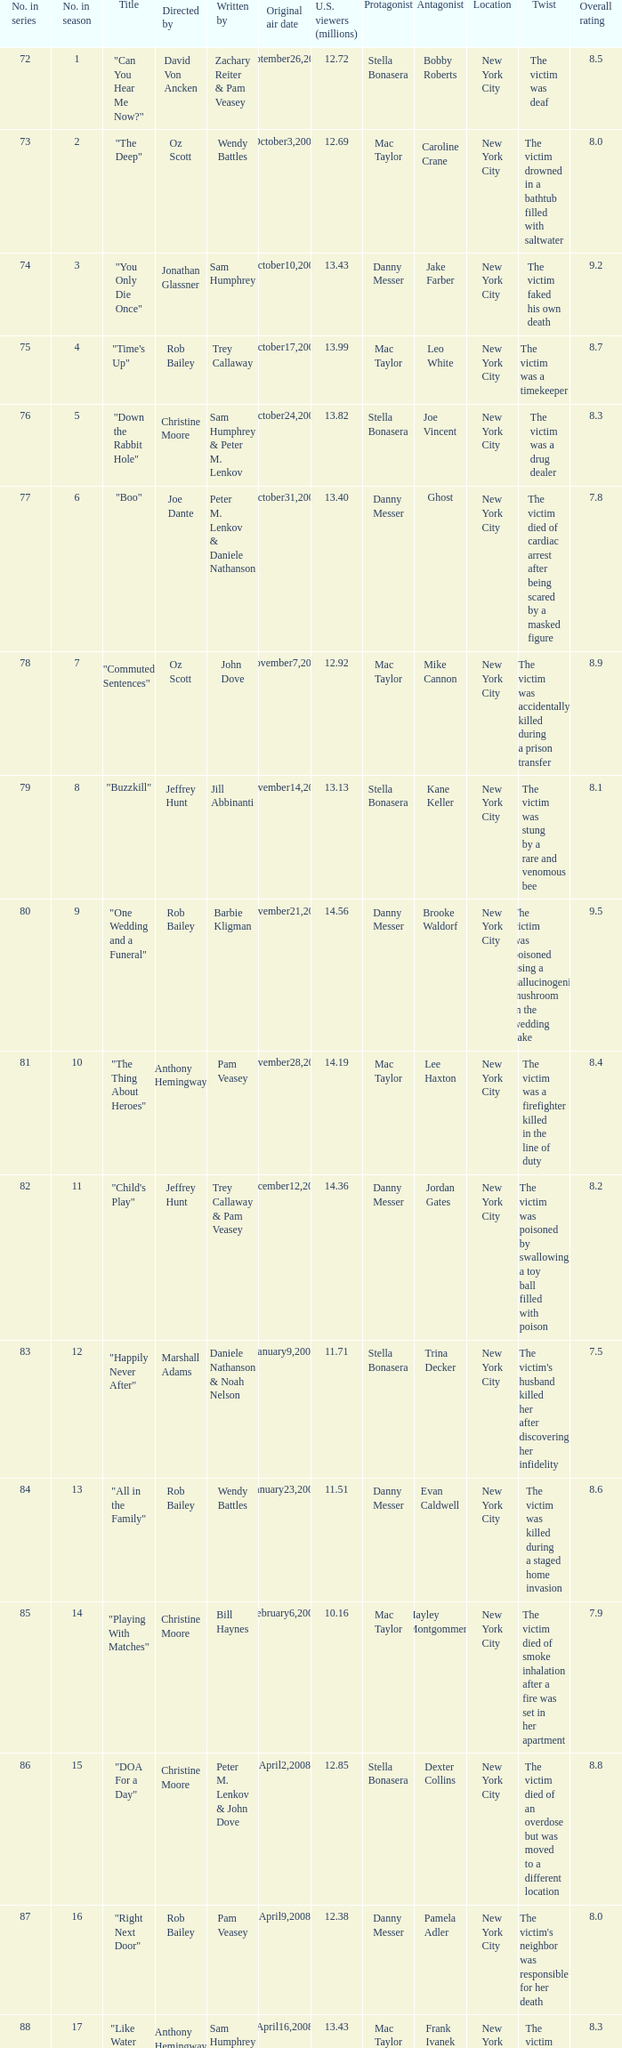Help me parse the entirety of this table. {'header': ['No. in series', 'No. in season', 'Title', 'Directed by', 'Written by', 'Original air date', 'U.S. viewers (millions)', 'Protagonist', 'Antagonist', 'Location', 'Twist', 'Overall rating'], 'rows': [['72', '1', '"Can You Hear Me Now?"', 'David Von Ancken', 'Zachary Reiter & Pam Veasey', 'September26,2007', '12.72', 'Stella Bonasera', 'Bobby Roberts', 'New York City', 'The victim was deaf', '8.5'], ['73', '2', '"The Deep"', 'Oz Scott', 'Wendy Battles', 'October3,2007', '12.69', 'Mac Taylor', 'Caroline Crane', 'New York City', 'The victim drowned in a bathtub filled with saltwater', '8.0'], ['74', '3', '"You Only Die Once"', 'Jonathan Glassner', 'Sam Humphrey', 'October10,2007', '13.43', 'Danny Messer', 'Jake Farber', 'New York City', 'The victim faked his own death', '9.2'], ['75', '4', '"Time\'s Up"', 'Rob Bailey', 'Trey Callaway', 'October17,2007', '13.99', 'Mac Taylor', 'Leo White', 'New York City', 'The victim was a timekeeper', '8.7'], ['76', '5', '"Down the Rabbit Hole"', 'Christine Moore', 'Sam Humphrey & Peter M. Lenkov', 'October24,2007', '13.82', 'Stella Bonasera', 'Joe Vincent', 'New York City', 'The victim was a drug dealer', '8.3'], ['77', '6', '"Boo"', 'Joe Dante', 'Peter M. Lenkov & Daniele Nathanson', 'October31,2007', '13.40', 'Danny Messer', 'Ghost', 'New York City', 'The victim died of cardiac arrest after being scared by a masked figure', '7.8'], ['78', '7', '"Commuted Sentences"', 'Oz Scott', 'John Dove', 'November7,2007', '12.92', 'Mac Taylor', 'Mike Cannon', 'New York City', 'The victim was accidentally killed during a prison transfer', '8.9'], ['79', '8', '"Buzzkill"', 'Jeffrey Hunt', 'Jill Abbinanti', 'November14,2007', '13.13', 'Stella Bonasera', 'Kane Keller', 'New York City', 'The victim was stung by a rare and venomous bee', '8.1'], ['80', '9', '"One Wedding and a Funeral"', 'Rob Bailey', 'Barbie Kligman', 'November21,2007', '14.56', 'Danny Messer', 'Brooke Waldorf', 'New York City', 'The victim was poisoned using a hallucinogenic mushroom in the wedding cake', '9.5'], ['81', '10', '"The Thing About Heroes"', 'Anthony Hemingway', 'Pam Veasey', 'November28,2007', '14.19', 'Mac Taylor', 'Lee Haxton', 'New York City', 'The victim was a firefighter killed in the line of duty', '8.4'], ['82', '11', '"Child\'s Play"', 'Jeffrey Hunt', 'Trey Callaway & Pam Veasey', 'December12,2007', '14.36', 'Danny Messer', 'Jordan Gates', 'New York City', 'The victim was poisoned by swallowing a toy ball filled with poison', '8.2'], ['83', '12', '"Happily Never After"', 'Marshall Adams', 'Daniele Nathanson & Noah Nelson', 'January9,2008', '11.71', 'Stella Bonasera', 'Trina Decker', 'New York City', "The victim's husband killed her after discovering her infidelity", '7.5'], ['84', '13', '"All in the Family"', 'Rob Bailey', 'Wendy Battles', 'January23,2008', '11.51', 'Danny Messer', 'Evan Caldwell', 'New York City', 'The victim was killed during a staged home invasion', '8.6'], ['85', '14', '"Playing With Matches"', 'Christine Moore', 'Bill Haynes', 'February6,2008', '10.16', 'Mac Taylor', 'Hayley Montgommery', 'New York City', 'The victim died of smoke inhalation after a fire was set in her apartment', '7.9'], ['86', '15', '"DOA For a Day"', 'Christine Moore', 'Peter M. Lenkov & John Dove', 'April2,2008', '12.85', 'Stella Bonasera', 'Dexter Collins', 'New York City', 'The victim died of an overdose but was moved to a different location', '8.8'], ['87', '16', '"Right Next Door"', 'Rob Bailey', 'Pam Veasey', 'April9,2008', '12.38', 'Danny Messer', 'Pamela Adler', 'New York City', "The victim's neighbor was responsible for her death", '8.0'], ['88', '17', '"Like Water For Murder"', 'Anthony Hemingway', 'Sam Humphrey', 'April16,2008', '13.43', 'Mac Taylor', 'Frank Ivanek', 'New York City', 'The victim was drowned in a bathtub filled with olive oil', '8.3'], ['89', '18', '"Admissions"', 'Rob Bailey', 'Zachary Reiter', 'April30,2008', '11.51', 'Stella Bonasera', 'Heather Kessler', 'New York City', 'The victim was killed by an unknown pathogen', '7.6'], ['90', '19', '"Personal Foul"', 'David Von Ancken', 'Trey Callaway', 'May7,2008', '12.73', 'Danny Messer', 'Clay Dobson', 'New York City', 'The victim was a high school basketball coach killed over a recruiting scandal', '8.9'], ['91', '20', '"Taxi"', 'Christine Moore', 'Barbie Kligman & John Dove', 'May14,2008', '11.86', 'Mac Taylor', 'Reynaldo Cortez', 'New York City', 'The victim was a taxi driver killed during a robbery gone wrong', '8.1']]} How many episodes were watched by 12.72 million U.S. viewers? 1.0. 